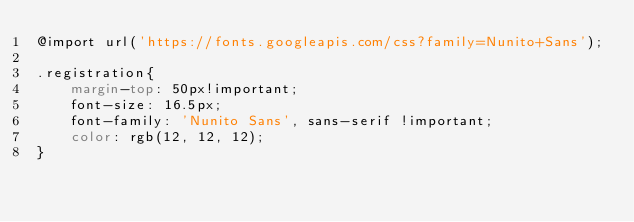<code> <loc_0><loc_0><loc_500><loc_500><_CSS_>@import url('https://fonts.googleapis.com/css?family=Nunito+Sans');

.registration{
    margin-top: 50px!important;
    font-size: 16.5px;
    font-family: 'Nunito Sans', sans-serif !important;
    color: rgb(12, 12, 12);
}
</code> 